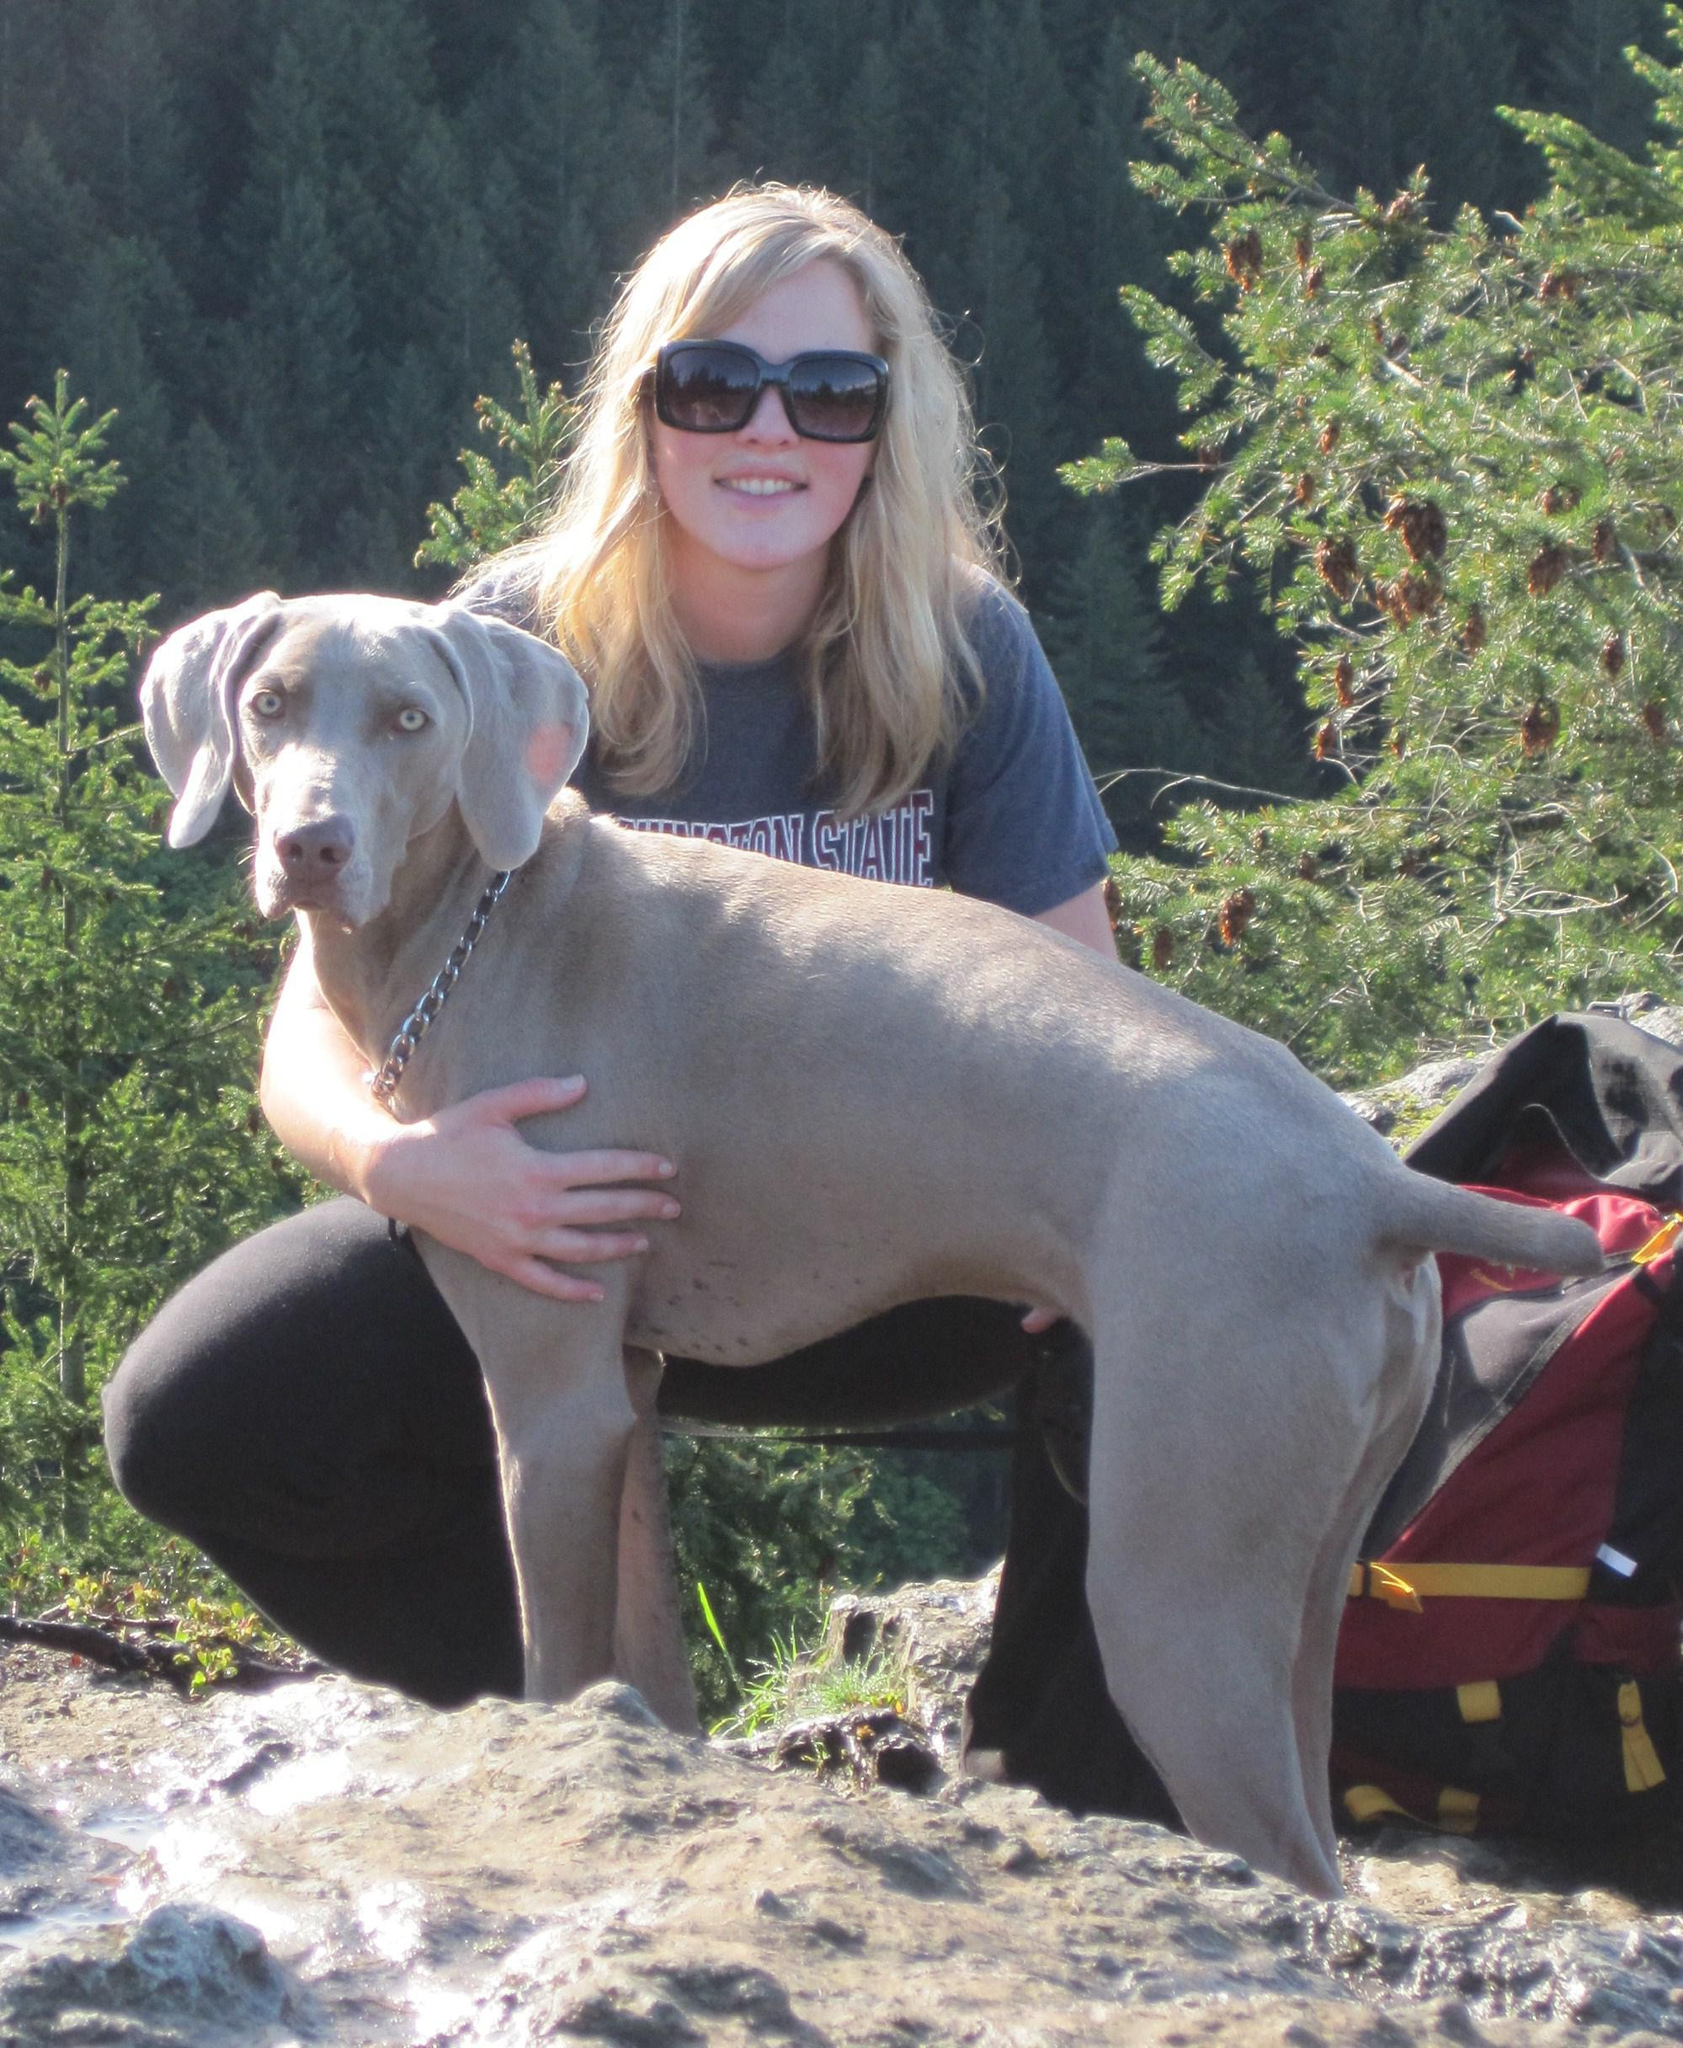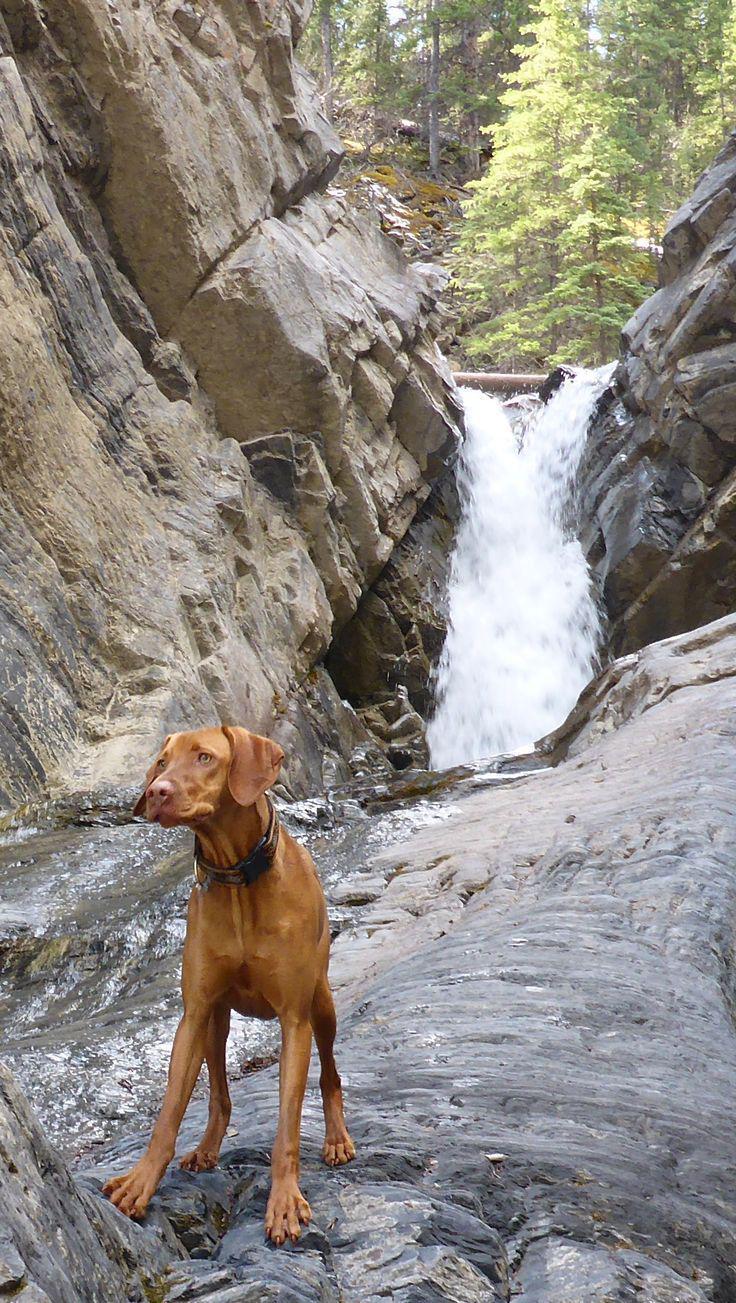The first image is the image on the left, the second image is the image on the right. Given the left and right images, does the statement "The combined images include a dog in the water and a dog moving forward while carrying something in its mouth." hold true? Answer yes or no. No. 